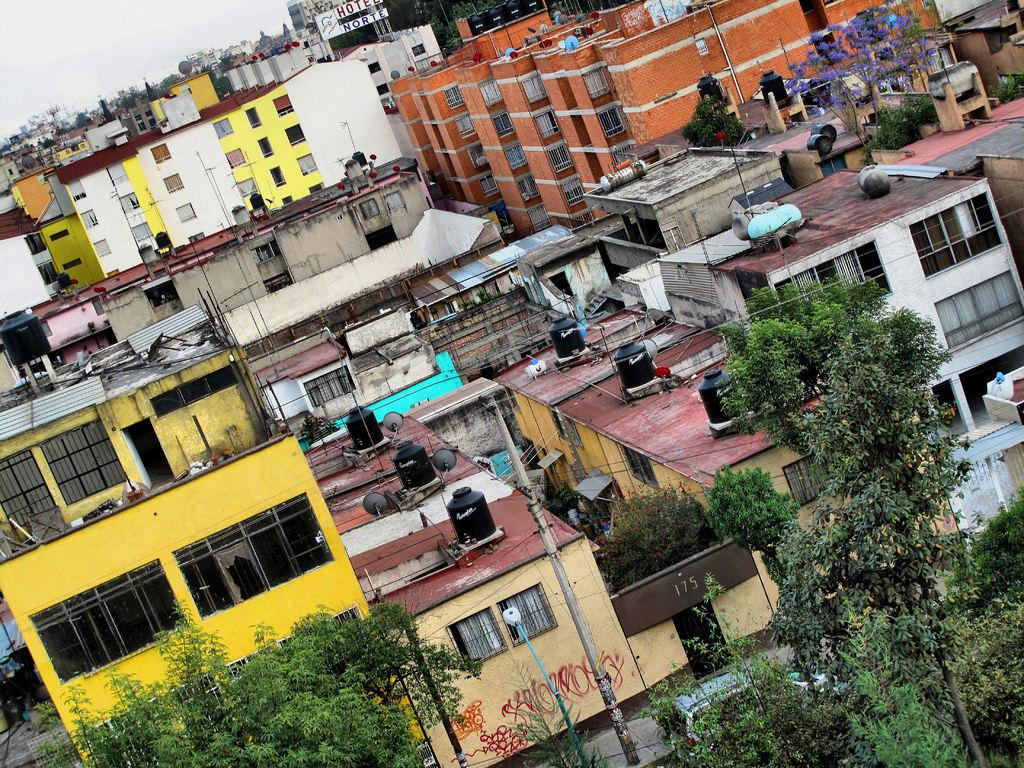What type of structures can be seen in the image? There are buildings in the image. What other natural elements are present in the image? There are trees in the image. What are the poles used for in the image? The purpose of the poles is not specified, but they could be used for various purposes such as streetlights or signage. What can be seen in the background of the image? The sky is visible in the background of the image. What type of poison is being used to control the growth of the trees in the image? There is no indication of any poison being used to control the growth of the trees in the image. 